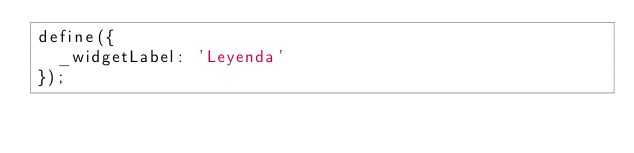Convert code to text. <code><loc_0><loc_0><loc_500><loc_500><_JavaScript_>define({
  _widgetLabel: 'Leyenda'
});</code> 